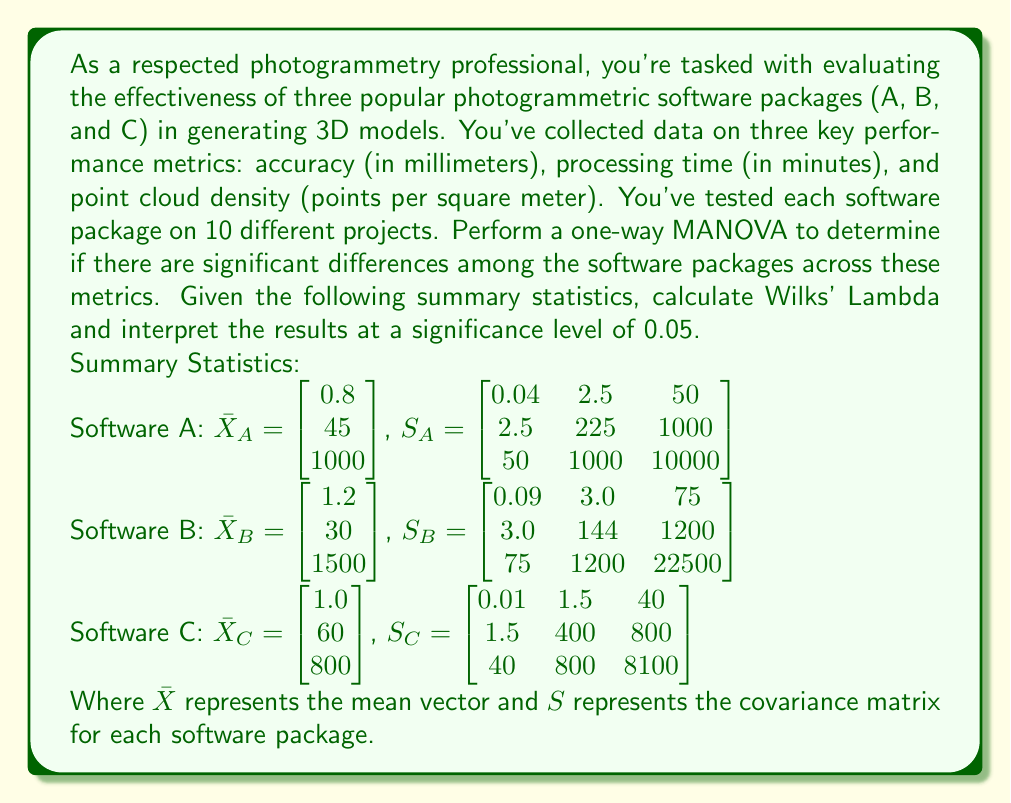Solve this math problem. To perform a one-way MANOVA and calculate Wilks' Lambda, we'll follow these steps:

1. Calculate the within-groups sum of squares and cross-products matrix (W):
   $W = (n_1 - 1)S_1 + (n_2 - 1)S_2 + (n_3 - 1)S_3$
   Where $n_1 = n_2 = n_3 = 10$ (10 projects per software)

   $W = 9S_A + 9S_B + 9S_C$
   $W = \begin{bmatrix} 1.26 & 63 & 1485 \\ 63 & 6921 & 27000 \\ 1485 & 27000 & 365400 \end{bmatrix}$

2. Calculate the total sum of squares and cross-products matrix (T):
   $T = W + B$
   Where B is the between-groups sum of squares and cross-products matrix

   To calculate B, we first need the grand mean:
   $\bar{X} = \frac{1}{3}(\bar{X}_A + \bar{X}_B + \bar{X}_C) = \begin{bmatrix} 1.0 \\ 45 \\ 1100 \end{bmatrix}$

   Now we can calculate B:
   $B = 10[(\bar{X}_A - \bar{X})(\bar{X}_A - \bar{X})' + (\bar{X}_B - \bar{X})(\bar{X}_B - \bar{X})' + (\bar{X}_C - \bar{X})(\bar{X}_C - \bar{X})']$

   $B = \begin{bmatrix} 0.80 & -75 & -1500 \\ -75 & 9000 & 45000 \\ -1500 & 45000 & 2430000 \end{bmatrix}$

   $T = W + B = \begin{bmatrix} 2.06 & -12 & -15 \\ -12 & 15921 & 72000 \\ -15 & 72000 & 2795400 \end{bmatrix}$

3. Calculate Wilks' Lambda:
   $\Lambda = \frac{|W|}{|T|}$

   $|W| = 3.0247 \times 10^9$
   $|T| = 8.7716 \times 10^9$

   $\Lambda = \frac{3.0247 \times 10^9}{8.7716 \times 10^9} = 0.3448$

4. Convert Wilks' Lambda to an F-statistic:
   $F = \frac{1-\Lambda^{1/t}}{\Lambda^{1/t}} \cdot \frac{df_2}{df_1}$

   Where:
   $t = 1$ (for one-way MANOVA)
   $df_1 = p(k-1) = 3(3-1) = 6$ (p = number of variables, k = number of groups)
   $df_2 = wt - 0.5(p - k + 1)$, where $w = n - k = 30 - 3 = 27$
   $df_2 = 27 - 0.5(3 - 3 + 1) = 26.5$

   $F = \frac{1-0.3448^{1/1}}{0.3448^{1/1}} \cdot \frac{26.5}{6} = 8.3940$

5. Compare the F-statistic to the critical value:
   The critical F-value for $df_1 = 6$, $df_2 = 26.5$, and $\alpha = 0.05$ is approximately 2.4286.

   Since our calculated F-statistic (8.3940) is greater than the critical value (2.4286), we reject the null hypothesis.
Answer: Wilks' Lambda = 0.3448

F-statistic = 8.3940

Interpretation: At a significance level of 0.05, we reject the null hypothesis. There are significant differences among the three photogrammetric software packages (A, B, and C) across the combined performance metrics of accuracy, processing time, and point cloud density. This suggests that the choice of software package has a significant impact on the 3D model generation process. 